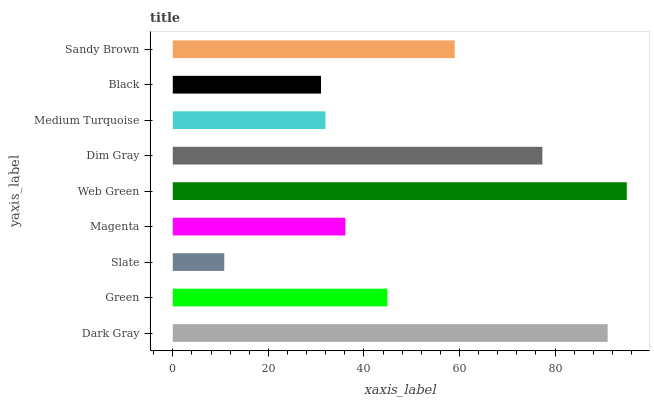Is Slate the minimum?
Answer yes or no. Yes. Is Web Green the maximum?
Answer yes or no. Yes. Is Green the minimum?
Answer yes or no. No. Is Green the maximum?
Answer yes or no. No. Is Dark Gray greater than Green?
Answer yes or no. Yes. Is Green less than Dark Gray?
Answer yes or no. Yes. Is Green greater than Dark Gray?
Answer yes or no. No. Is Dark Gray less than Green?
Answer yes or no. No. Is Green the high median?
Answer yes or no. Yes. Is Green the low median?
Answer yes or no. Yes. Is Dark Gray the high median?
Answer yes or no. No. Is Medium Turquoise the low median?
Answer yes or no. No. 